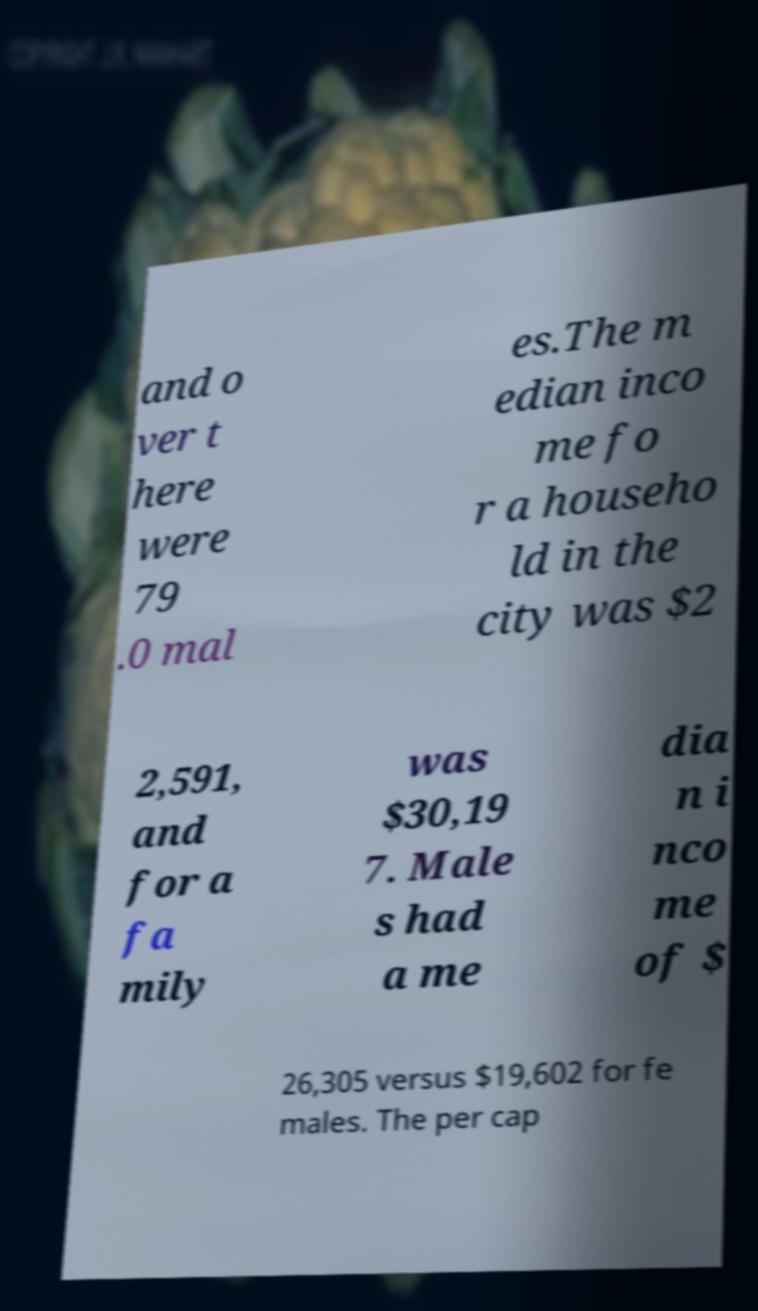For documentation purposes, I need the text within this image transcribed. Could you provide that? and o ver t here were 79 .0 mal es.The m edian inco me fo r a househo ld in the city was $2 2,591, and for a fa mily was $30,19 7. Male s had a me dia n i nco me of $ 26,305 versus $19,602 for fe males. The per cap 